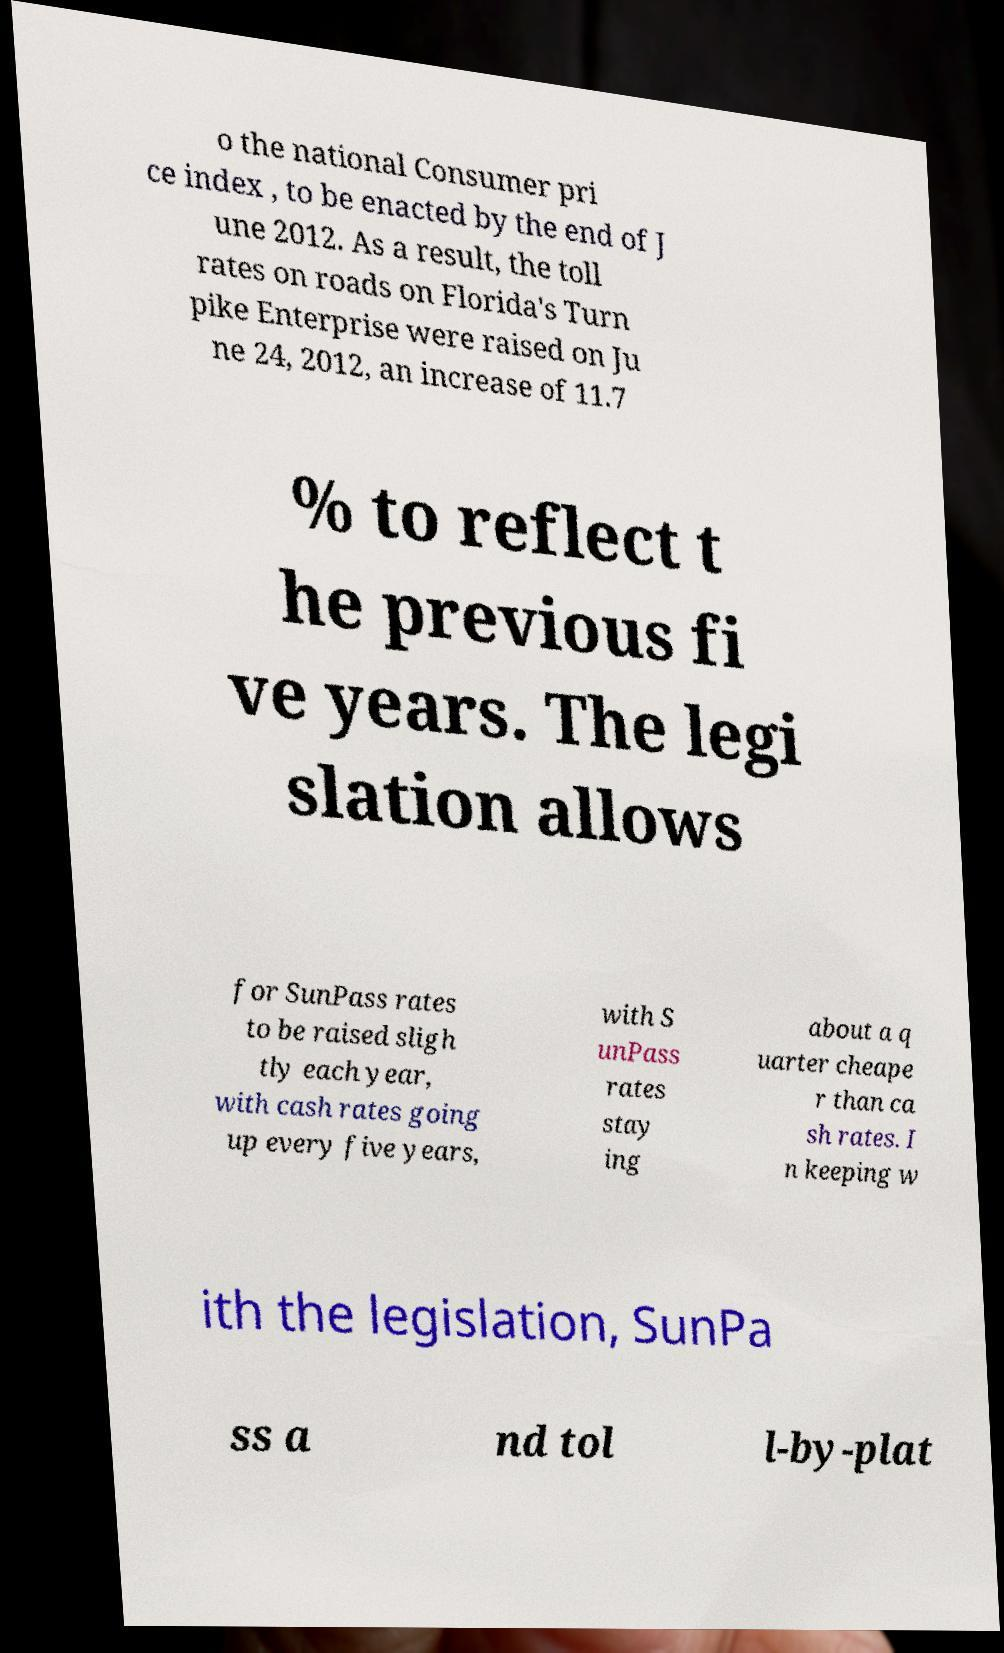Could you assist in decoding the text presented in this image and type it out clearly? o the national Consumer pri ce index , to be enacted by the end of J une 2012. As a result, the toll rates on roads on Florida's Turn pike Enterprise were raised on Ju ne 24, 2012, an increase of 11.7 % to reflect t he previous fi ve years. The legi slation allows for SunPass rates to be raised sligh tly each year, with cash rates going up every five years, with S unPass rates stay ing about a q uarter cheape r than ca sh rates. I n keeping w ith the legislation, SunPa ss a nd tol l-by-plat 